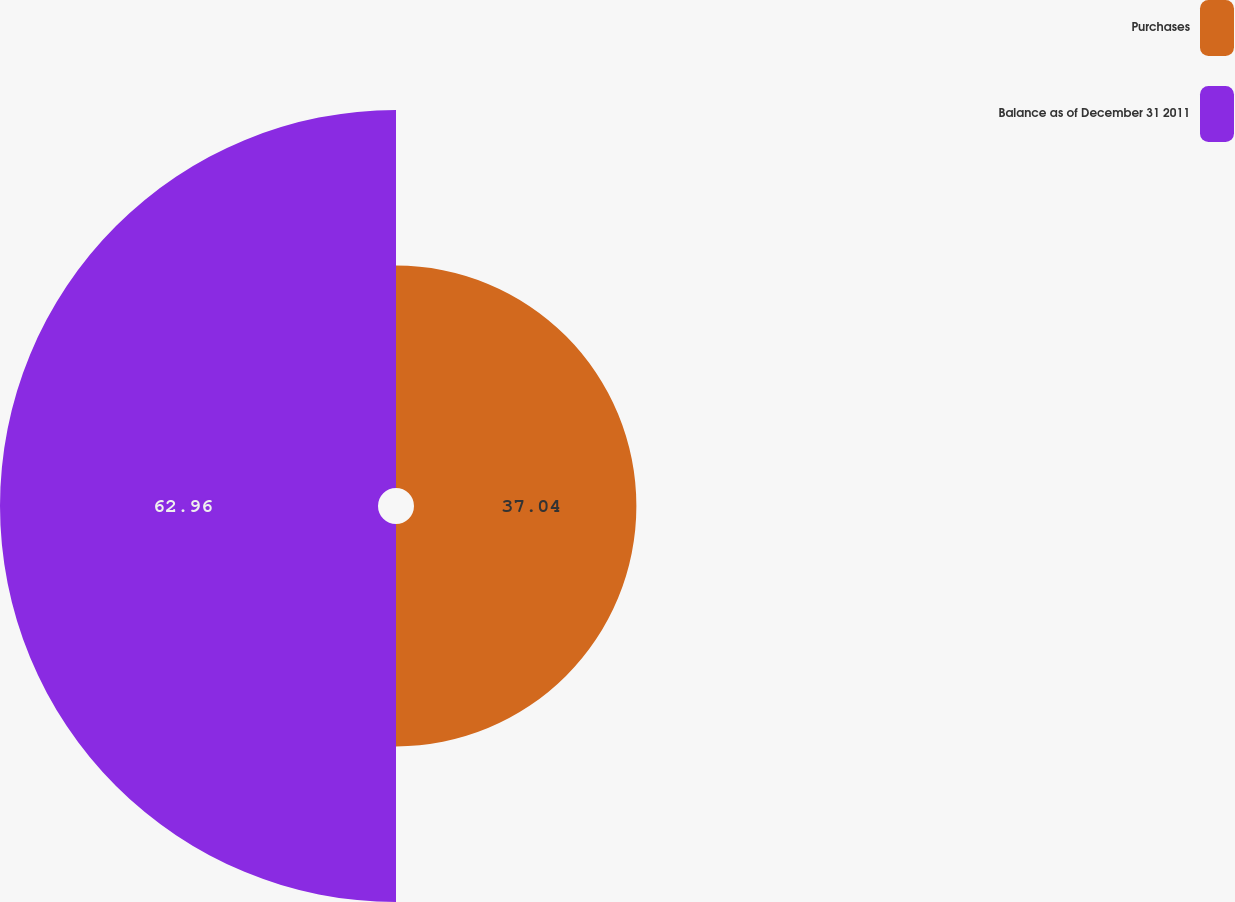Convert chart. <chart><loc_0><loc_0><loc_500><loc_500><pie_chart><fcel>Purchases<fcel>Balance as of December 31 2011<nl><fcel>37.04%<fcel>62.96%<nl></chart> 